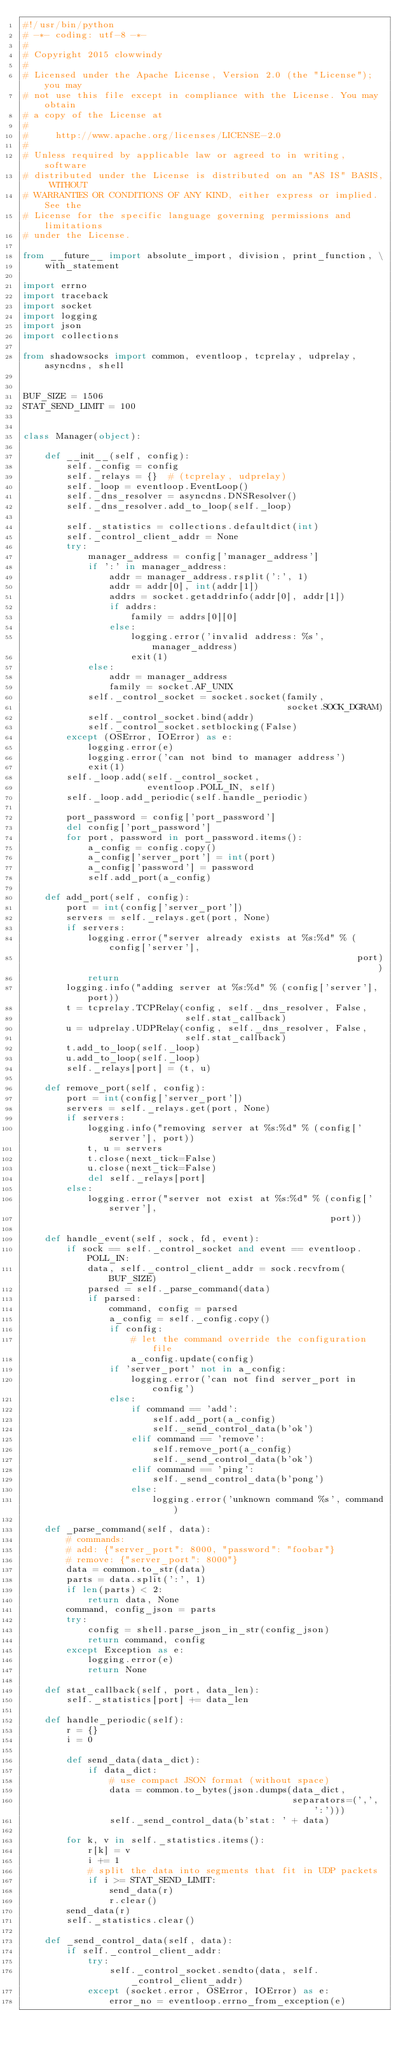Convert code to text. <code><loc_0><loc_0><loc_500><loc_500><_Python_>#!/usr/bin/python
# -*- coding: utf-8 -*-
#
# Copyright 2015 clowwindy
#
# Licensed under the Apache License, Version 2.0 (the "License"); you may
# not use this file except in compliance with the License. You may obtain
# a copy of the License at
#
#     http://www.apache.org/licenses/LICENSE-2.0
#
# Unless required by applicable law or agreed to in writing, software
# distributed under the License is distributed on an "AS IS" BASIS, WITHOUT
# WARRANTIES OR CONDITIONS OF ANY KIND, either express or implied. See the
# License for the specific language governing permissions and limitations
# under the License.

from __future__ import absolute_import, division, print_function, \
    with_statement

import errno
import traceback
import socket
import logging
import json
import collections

from shadowsocks import common, eventloop, tcprelay, udprelay, asyncdns, shell


BUF_SIZE = 1506
STAT_SEND_LIMIT = 100


class Manager(object):

    def __init__(self, config):
        self._config = config
        self._relays = {}  # (tcprelay, udprelay)
        self._loop = eventloop.EventLoop()
        self._dns_resolver = asyncdns.DNSResolver()
        self._dns_resolver.add_to_loop(self._loop)

        self._statistics = collections.defaultdict(int)
        self._control_client_addr = None
        try:
            manager_address = config['manager_address']
            if ':' in manager_address:
                addr = manager_address.rsplit(':', 1)
                addr = addr[0], int(addr[1])
                addrs = socket.getaddrinfo(addr[0], addr[1])
                if addrs:
                    family = addrs[0][0]
                else:
                    logging.error('invalid address: %s', manager_address)
                    exit(1)
            else:
                addr = manager_address
                family = socket.AF_UNIX
            self._control_socket = socket.socket(family,
                                                 socket.SOCK_DGRAM)
            self._control_socket.bind(addr)
            self._control_socket.setblocking(False)
        except (OSError, IOError) as e:
            logging.error(e)
            logging.error('can not bind to manager address')
            exit(1)
        self._loop.add(self._control_socket,
                       eventloop.POLL_IN, self)
        self._loop.add_periodic(self.handle_periodic)

        port_password = config['port_password']
        del config['port_password']
        for port, password in port_password.items():
            a_config = config.copy()
            a_config['server_port'] = int(port)
            a_config['password'] = password
            self.add_port(a_config)

    def add_port(self, config):
        port = int(config['server_port'])
        servers = self._relays.get(port, None)
        if servers:
            logging.error("server already exists at %s:%d" % (config['server'],
                                                              port))
            return
        logging.info("adding server at %s:%d" % (config['server'], port))
        t = tcprelay.TCPRelay(config, self._dns_resolver, False,
                              self.stat_callback)
        u = udprelay.UDPRelay(config, self._dns_resolver, False,
                              self.stat_callback)
        t.add_to_loop(self._loop)
        u.add_to_loop(self._loop)
        self._relays[port] = (t, u)

    def remove_port(self, config):
        port = int(config['server_port'])
        servers = self._relays.get(port, None)
        if servers:
            logging.info("removing server at %s:%d" % (config['server'], port))
            t, u = servers
            t.close(next_tick=False)
            u.close(next_tick=False)
            del self._relays[port]
        else:
            logging.error("server not exist at %s:%d" % (config['server'],
                                                         port))

    def handle_event(self, sock, fd, event):
        if sock == self._control_socket and event == eventloop.POLL_IN:
            data, self._control_client_addr = sock.recvfrom(BUF_SIZE)
            parsed = self._parse_command(data)
            if parsed:
                command, config = parsed
                a_config = self._config.copy()
                if config:
                    # let the command override the configuration file
                    a_config.update(config)
                if 'server_port' not in a_config:
                    logging.error('can not find server_port in config')
                else:
                    if command == 'add':
                        self.add_port(a_config)
                        self._send_control_data(b'ok')
                    elif command == 'remove':
                        self.remove_port(a_config)
                        self._send_control_data(b'ok')
                    elif command == 'ping':
                        self._send_control_data(b'pong')
                    else:
                        logging.error('unknown command %s', command)

    def _parse_command(self, data):
        # commands:
        # add: {"server_port": 8000, "password": "foobar"}
        # remove: {"server_port": 8000"}
        data = common.to_str(data)
        parts = data.split(':', 1)
        if len(parts) < 2:
            return data, None
        command, config_json = parts
        try:
            config = shell.parse_json_in_str(config_json)
            return command, config
        except Exception as e:
            logging.error(e)
            return None

    def stat_callback(self, port, data_len):
        self._statistics[port] += data_len

    def handle_periodic(self):
        r = {}
        i = 0

        def send_data(data_dict):
            if data_dict:
                # use compact JSON format (without space)
                data = common.to_bytes(json.dumps(data_dict,
                                                  separators=(',', ':')))
                self._send_control_data(b'stat: ' + data)

        for k, v in self._statistics.items():
            r[k] = v
            i += 1
            # split the data into segments that fit in UDP packets
            if i >= STAT_SEND_LIMIT:
                send_data(r)
                r.clear()
        send_data(r)
        self._statistics.clear()

    def _send_control_data(self, data):
        if self._control_client_addr:
            try:
                self._control_socket.sendto(data, self._control_client_addr)
            except (socket.error, OSError, IOError) as e:
                error_no = eventloop.errno_from_exception(e)</code> 